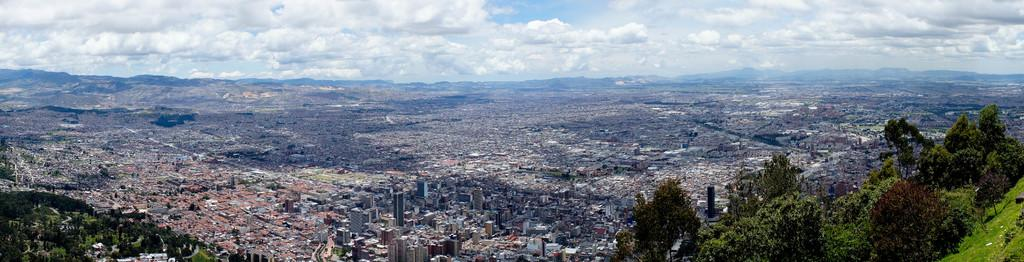What type of view is shown in the image? The image is a top view of a city. What structures can be seen in the image? There are buildings in the image. What type of vegetation is present in the image? There are trees in the image. What is visible at the top of the image? The sky is visible at the top of the image. What can be observed in the sky? Clouds are present in the sky. How does the door in the image open and close? There is no door present in the image; it is a top view of a city with buildings, trees, and sky. 